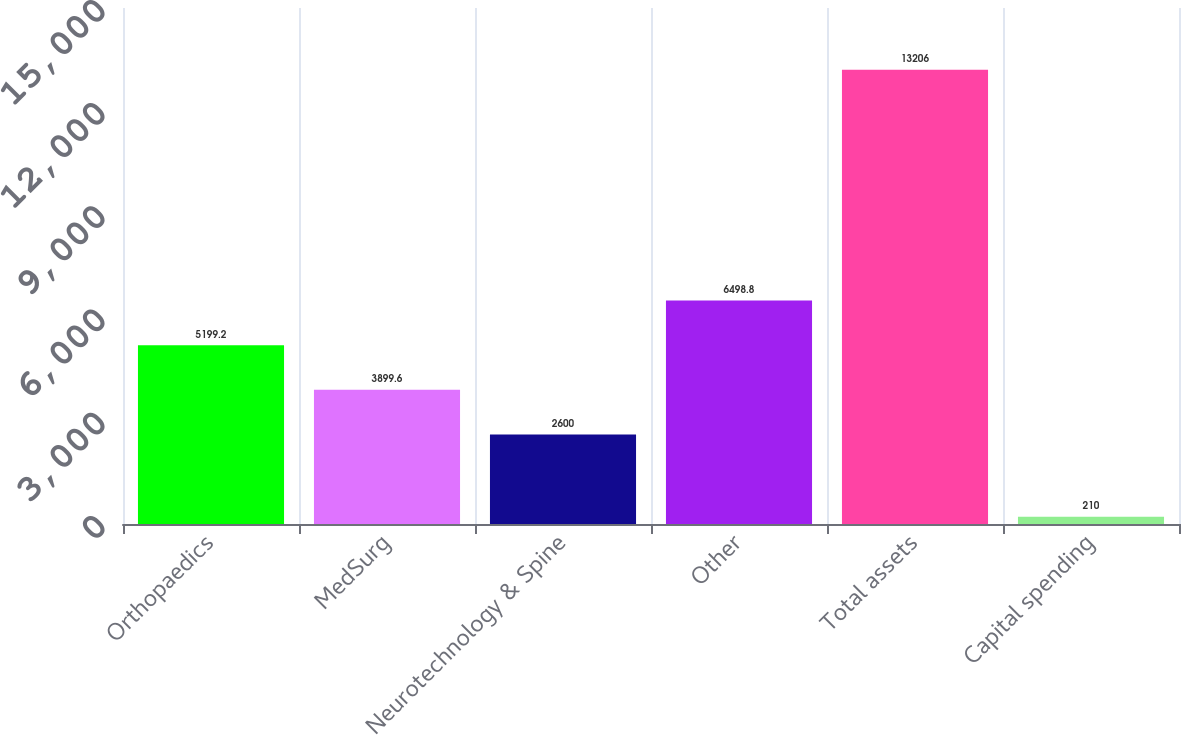Convert chart to OTSL. <chart><loc_0><loc_0><loc_500><loc_500><bar_chart><fcel>Orthopaedics<fcel>MedSurg<fcel>Neurotechnology & Spine<fcel>Other<fcel>Total assets<fcel>Capital spending<nl><fcel>5199.2<fcel>3899.6<fcel>2600<fcel>6498.8<fcel>13206<fcel>210<nl></chart> 